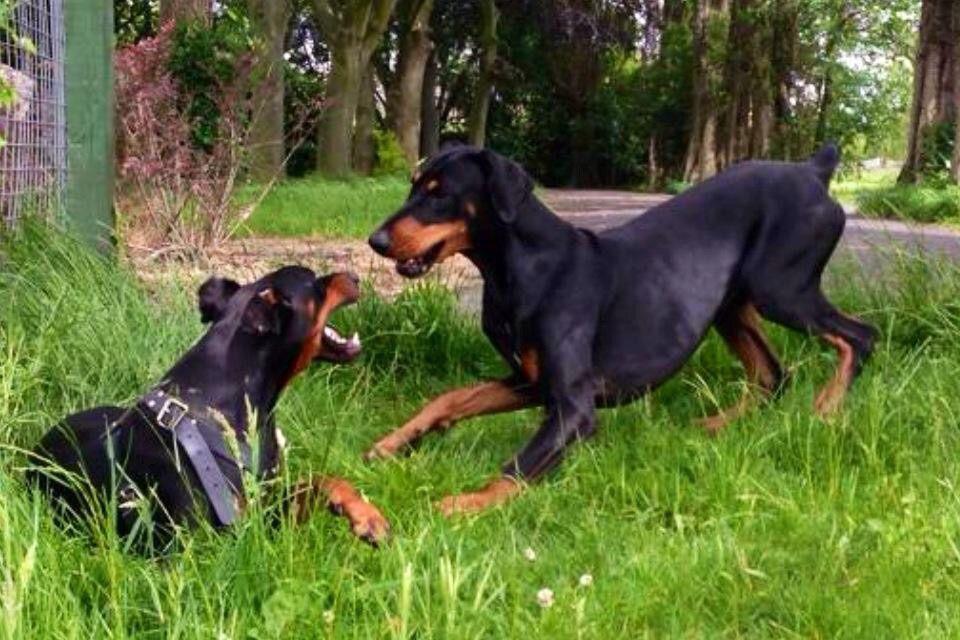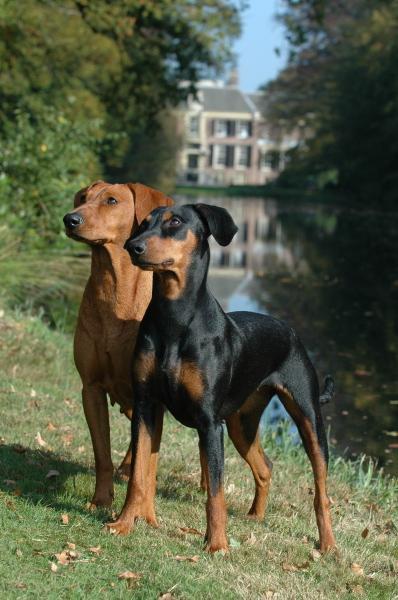The first image is the image on the left, the second image is the image on the right. Assess this claim about the two images: "At least one doberman has its tongue out.". Correct or not? Answer yes or no. No. The first image is the image on the left, the second image is the image on the right. Given the left and right images, does the statement "In one image, there are two dogs facing each other." hold true? Answer yes or no. Yes. 